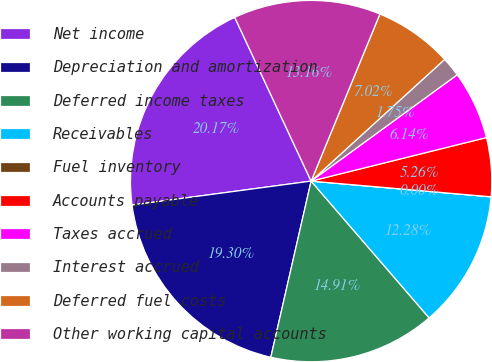Convert chart. <chart><loc_0><loc_0><loc_500><loc_500><pie_chart><fcel>Net income<fcel>Depreciation and amortization<fcel>Deferred income taxes<fcel>Receivables<fcel>Fuel inventory<fcel>Accounts payable<fcel>Taxes accrued<fcel>Interest accrued<fcel>Deferred fuel costs<fcel>Other working capital accounts<nl><fcel>20.17%<fcel>19.3%<fcel>14.91%<fcel>12.28%<fcel>0.0%<fcel>5.26%<fcel>6.14%<fcel>1.75%<fcel>7.02%<fcel>13.16%<nl></chart> 